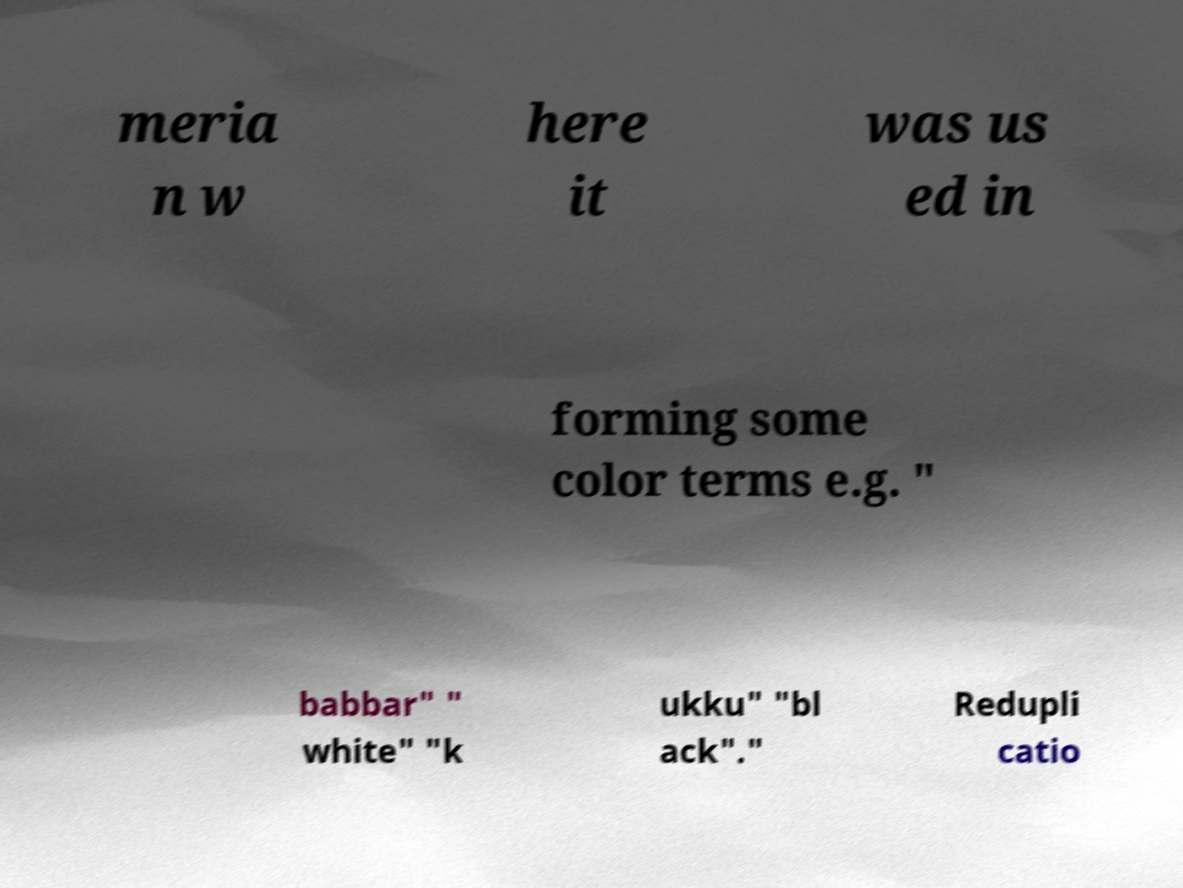For documentation purposes, I need the text within this image transcribed. Could you provide that? meria n w here it was us ed in forming some color terms e.g. " babbar" " white" "k ukku" "bl ack"." Redupli catio 